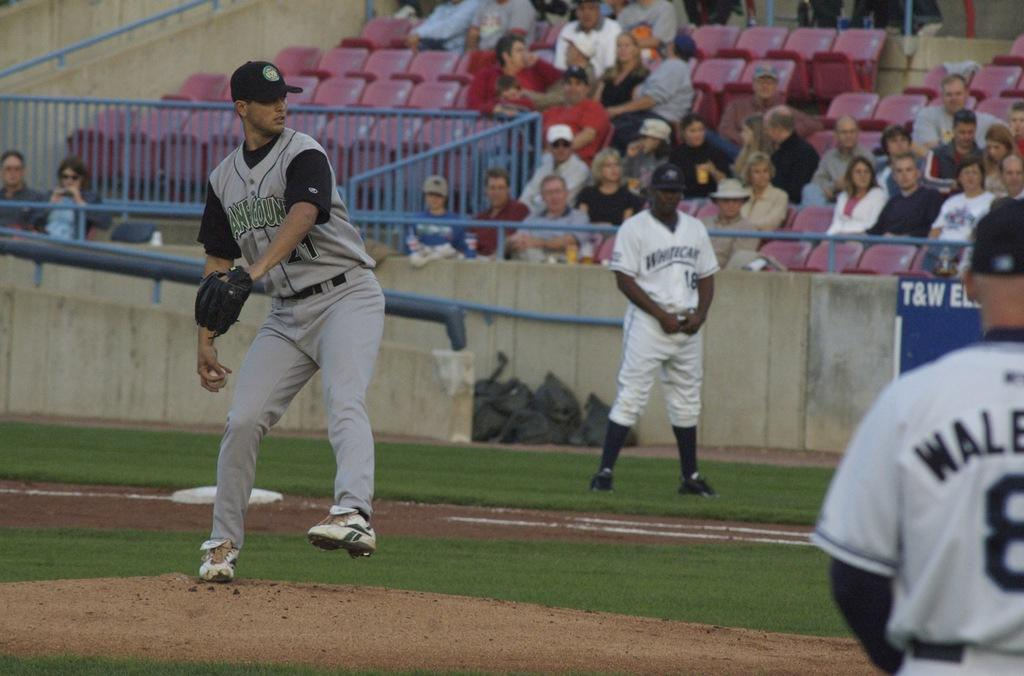<image>
Summarize the visual content of the image. A baseball game is underway and a blue sign says T&W. 